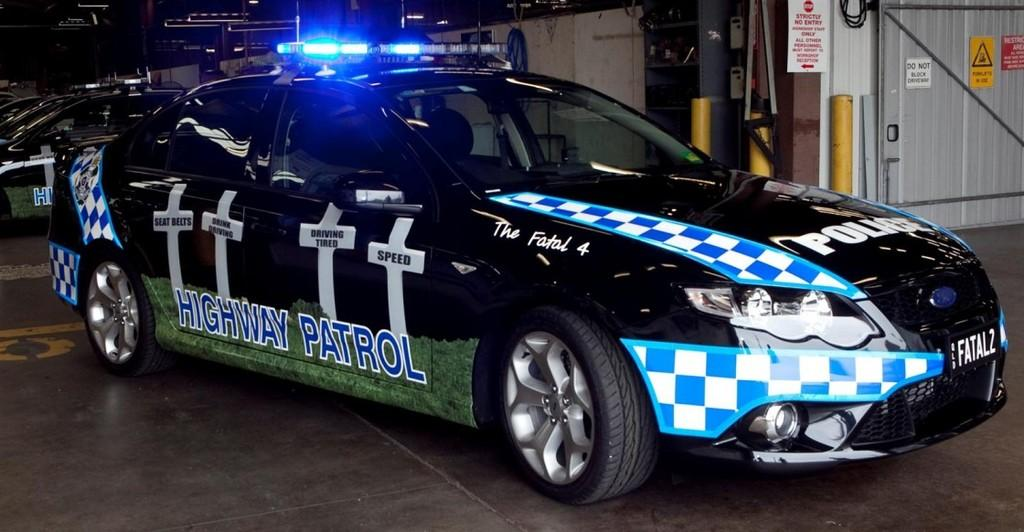What types of objects are present in the image? There are vehicles in the image. Where are the vehicles located in relation to other structures? The vehicles are beside a wall. Is there any entrance or exit visible in the image? Yes, there is a gate in the top right of the image. Can you see any boats or the ocean in the image? No, there are no boats or ocean visible in the image. Is there an oven present in the image? No, there is no oven present in the image. 